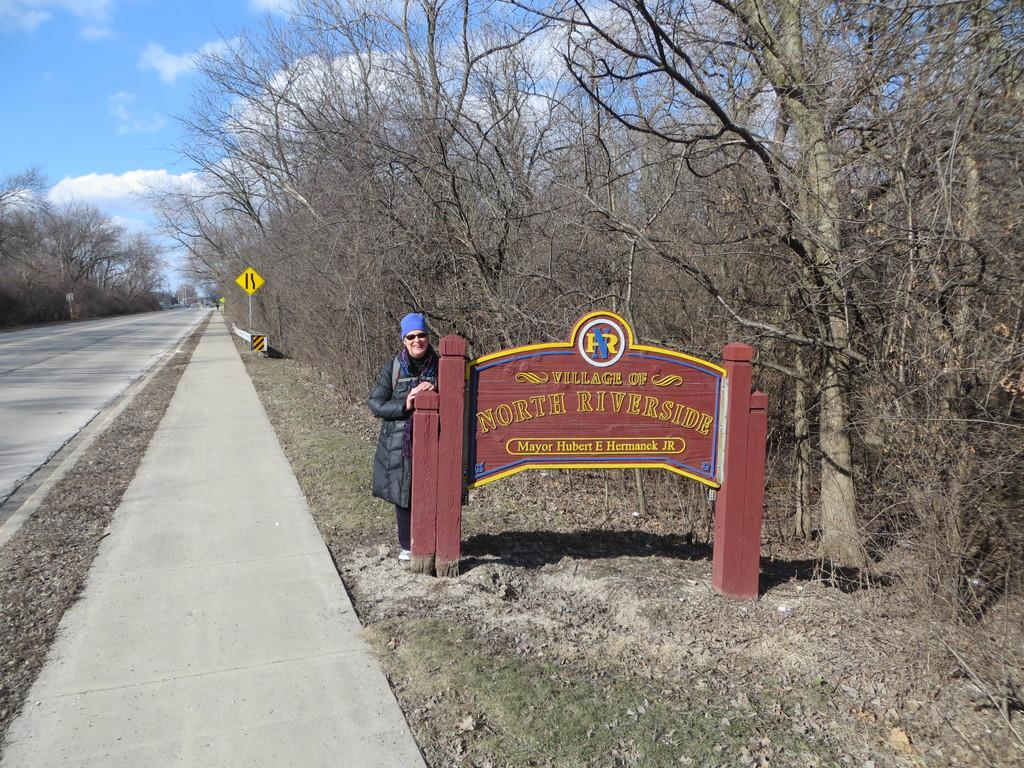<image>
Give a short and clear explanation of the subsequent image. A person wearing a blue cap is standing by a sign that says Village of North Riverside. 